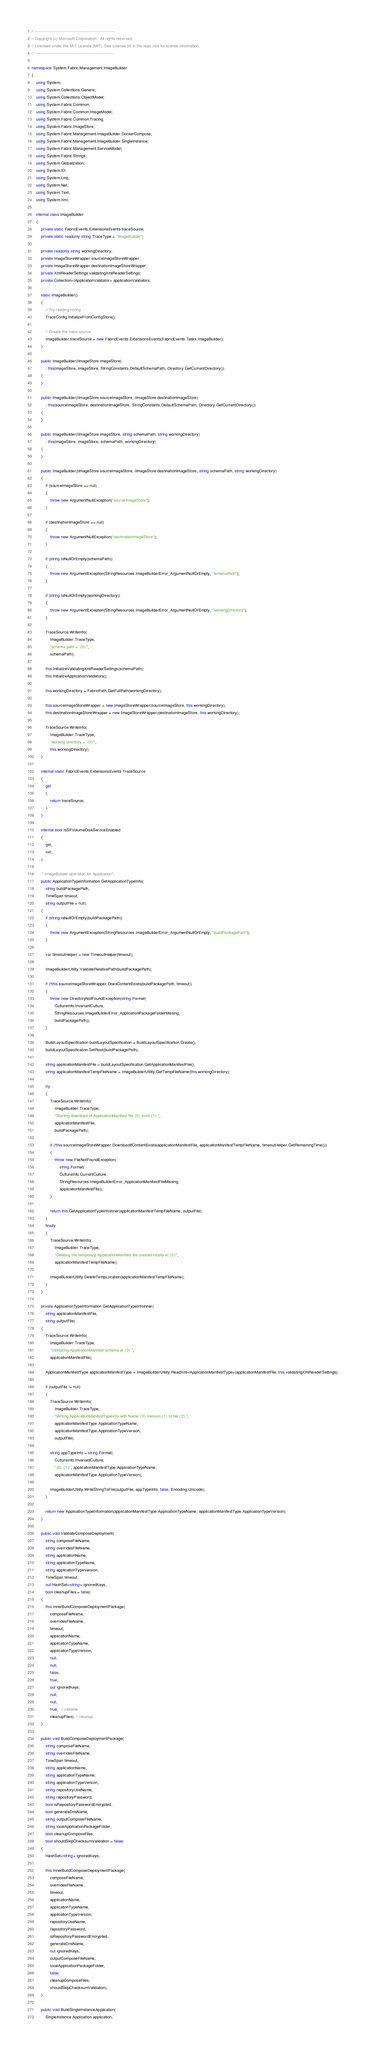Convert code to text. <code><loc_0><loc_0><loc_500><loc_500><_C#_>// ------------------------------------------------------------
// Copyright (c) Microsoft Corporation.  All rights reserved.
// Licensed under the MIT License (MIT). See License.txt in the repo root for license information.
// ------------------------------------------------------------

namespace System.Fabric.Management.ImageBuilder
{
    using System;
    using System.Collections.Generic;
    using System.Collections.ObjectModel;
    using System.Fabric.Common;
    using System.Fabric.Common.ImageModel;
    using System.Fabric.Common.Tracing;
    using System.Fabric.ImageStore;
    using System.Fabric.Management.ImageBuilder.DockerCompose;
    using System.Fabric.Management.ImageBuilder.SingleInstance;
    using System.Fabric.Management.ServiceModel;
    using System.Fabric.Strings;
    using System.Globalization;
    using System.IO;
    using System.Linq;
    using System.Net;
    using System.Text;
    using System.Xml;

    internal class ImageBuilder
    {
        private static FabricEvents.ExtensionsEvents traceSource;
        private static readonly string TraceType = "ImageBuilder";
        
        private readonly string workingDirectory;
        private ImageStoreWrapper sourceImageStoreWrapper;        
        private ImageStoreWrapper destinationImageStoreWrapper;        
        private XmlReaderSettings validatingXmlReaderSettings;
        private Collection<IApplicationValidator> applicationValidators;

        static ImageBuilder()
        {
            // Try reading config
            TraceConfig.InitializeFromConfigStore();

            // Create the trace source
            ImageBuilder.traceSource = new FabricEvents.ExtensionsEvents(FabricEvents.Tasks.ImageBuilder);
        }
        
        public ImageBuilder(IImageStore imageStore)
            : this(imageStore, imageStore, StringConstants.DefaultSchemaPath, Directory.GetCurrentDirectory())
        {
        }

        public ImageBuilder(IImageStore sourceImageStore, IImageStore destinationImageStore)
            : this(sourceImageStore, destinationImageStore, StringConstants.DefaultSchemaPath, Directory.GetCurrentDirectory())
        {
        }

        public ImageBuilder(IImageStore imageStore, string schemaPath, string workingDirectory)
            : this(imageStore, imageStore, schemaPath, workingDirectory)
        {
        }

        public ImageBuilder(IImageStore sourceImageStore, IImageStore destinationImageStore, string schemaPath, string workingDirectory)
        {
            if (sourceImageStore == null)
            {
                throw new ArgumentNullException("sourceImageStore");
            } 
            
            if (destinationImageStore == null)
            {
                throw new ArgumentNullException("destinationImageStore");
            }

            if (string.IsNullOrEmpty(schemaPath))
            {
                throw new ArgumentException(StringResources.ImageBuilderError_ArgumentNullOrEmpty, "schemaPath");
            }

            if (string.IsNullOrEmpty(workingDirectory))
            {
                throw new ArgumentException(StringResources.ImageBuilderError_ArgumentNullOrEmpty, "workingDirectory");
            }

            TraceSource.WriteInfo(
                ImageBuilder.TraceType,
                "schema path = '{0}'",
                schemaPath);

            this.InitializeValidatingXmlReaderSettings(schemaPath);
            this.InitializeApplicationValidators();

            this.workingDirectory = FabricPath.GetFullPath(workingDirectory);

            this.sourceImageStoreWrapper = new ImageStoreWrapper(sourceImageStore, this.workingDirectory);
            this.destinationImageStoreWrapper = new ImageStoreWrapper(destinationImageStore, this.workingDirectory);

            TraceSource.WriteInfo(
                ImageBuilder.TraceType,
                "working directory = '{0}'",
                this.workingDirectory);
        }

        internal static FabricEvents.ExtensionsEvents TraceSource
        {
            get
            {
                return traceSource;
            }
        }

        internal bool IsSFVolumeDiskServiceEnabled
        {
            get;
            set;
        }

        /* ImageBuilder operation for Application*/
        public ApplicationTypeInformation GetApplicationTypeInfo(
            string buildPackagePath,
            TimeSpan timeout,
            string outputFile = null)
        {
            if (string.IsNullOrEmpty(buildPackagePath))
            {
                throw new ArgumentException(StringResources.ImageBuilderError_ArgumentNullOrEmpty, "buildPackagePath");
            }

            var timeoutHelper = new TimeoutHelper(timeout);

            ImageBuilderUtility.ValidateRelativePath(buildPackagePath);

            if (!this.sourceImageStoreWrapper.DoesContentExists(buildPackagePath, timeout))
            {
                throw new DirectoryNotFoundException(string.Format(
                    CultureInfo.InvariantCulture,
                    StringResources.ImageBuilderError_ApplicationPackageFolderMissing,
                    buildPackagePath));
            }

            BuildLayoutSpecification buildLayoutSpecification = BuildLayoutSpecification.Create();
            buildLayoutSpecification.SetRoot(buildPackagePath);

            string applicationManifestFile = buildLayoutSpecification.GetApplicationManifestFile();
            string applicationManifestTempFileName = ImageBuilderUtility.GetTempFileName(this.workingDirectory);

            try
            {
                TraceSource.WriteInfo(
                    ImageBuilder.TraceType,
                    "Starting download of ApplicationManifest file {0} from {1}.",
                    applicationManifestFile,
                    buildPackagePath);

                if (!this.sourceImageStoreWrapper.DownloadIfContentExists(applicationManifestFile, applicationManifestTempFileName, timeoutHelper.GetRemainingTime()))
                {
                    throw new FileNotFoundException(
                        string.Format(
                        CultureInfo.CurrentCulture,
                        StringResources.ImageBuilderError_ApplicationManifestFileMissing,
                        applicationManifestFile));
                }

                return this.GetApplicationTypeInfoInner(applicationManifestTempFileName, outputFile);
            }
            finally
            {
                TraceSource.WriteInfo(
                    ImageBuilder.TraceType,
                    "Deleting the temporary ApplicationManifest file created locally at {0}",
                    applicationManifestTempFileName);

                ImageBuilderUtility.DeleteTempLocation(applicationManifestTempFileName);
            }
        }

        private ApplicationTypeInformation GetApplicationTypeInfoInner(
            string applicationManifestFile,
            string outputFile)
        {
            TraceSource.WriteInfo(
                ImageBuilder.TraceType,
                "Validating ApplicationManifest schema at {0}.",
                applicationManifestFile);

            ApplicationManifestType applicationManifestType = ImageBuilderUtility.ReadXml<ApplicationManifestType>(applicationManifestFile, this.validatingXmlReaderSettings);

            if (outputFile != null)
            {
                TraceSource.WriteInfo(
                    ImageBuilder.TraceType,
                    "Writing ApplicationManifestTypeInfo with Name:{0} Version:{1} to file {2}.",
                    applicationManifestType.ApplicationTypeName,
                    applicationManifestType.ApplicationTypeVersion,
                    outputFile);

                string appTypeInfo = string.Format(
                    CultureInfo.InvariantCulture,
                    "{0}:{1}", applicationManifestType.ApplicationTypeName,
                    applicationManifestType.ApplicationTypeVersion);

                ImageBuilderUtility.WriteStringToFile(outputFile, appTypeInfo, false, Encoding.Unicode);
            }

            return new ApplicationTypeInformation(applicationManifestType.ApplicationTypeName, applicationManifestType.ApplicationTypeVersion);
        }

        public void ValidateComposeDeployment(
            string composeFileName,
            string overridesFileName,
            string applicationName,
            string applicationTypeName,
            string applicationTypeVersion,
            TimeSpan timeout,
            out HashSet<string> ignoredKeys,
            bool cleanupFiles = false)
        {
            this.InnerBuildComposeDeploymentPackage(
                composeFileName,
                overridesFileName,
                timeout,
                applicationName,
                applicationTypeName,
                applicationTypeVersion,
                null,
                null,
                false,
                true,
                out ignoredKeys,
                null,
                null,
                true,  // validate
                cleanupFiles); // cleanup
        }

        public void BuildComposeDeploymentPackage(
            string composeFileName,
            string overridesFileName,
            TimeSpan timeout,
            string applicationName,
            string applicationTypeName,
            string applicationTypeVersion,
            string repositoryUseName,
            string repositoryPassword,
            bool isRepositoryPasswordEncrypted,
            bool generateDnsName,
            string outputComposeFileName,
            string localApplicationPackageFolder,
            bool cleanupComposeFiles,
            bool shouldSkipChecksumValidation = false)
        {
            HashSet<string> ignoredKeys;

            this.InnerBuildComposeDeploymentPackage(
                composeFileName,
                overridesFileName,
                timeout,
                applicationName,
                applicationTypeName,
                applicationTypeVersion,
                repositoryUseName,
                repositoryPassword,
                isRepositoryPasswordEncrypted,
                generateDnsName,
                out ignoredKeys,
                outputComposeFileName,
                localApplicationPackageFolder,
                false,
                cleanupComposeFiles,
                shouldSkipChecksumValidation);
        }

        public void BuildSingleInstanceApplication(
            SingleInstance.Application application,</code> 